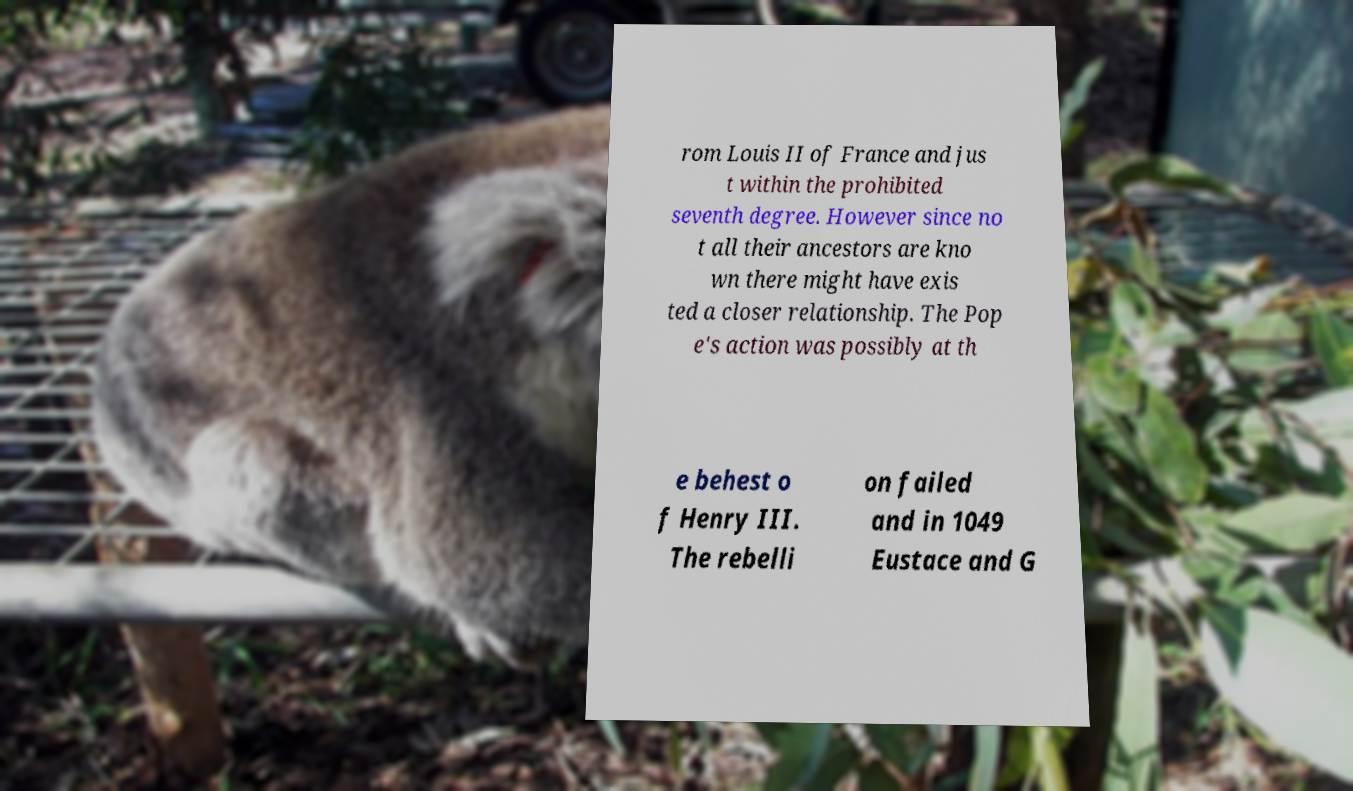Can you read and provide the text displayed in the image?This photo seems to have some interesting text. Can you extract and type it out for me? rom Louis II of France and jus t within the prohibited seventh degree. However since no t all their ancestors are kno wn there might have exis ted a closer relationship. The Pop e's action was possibly at th e behest o f Henry III. The rebelli on failed and in 1049 Eustace and G 